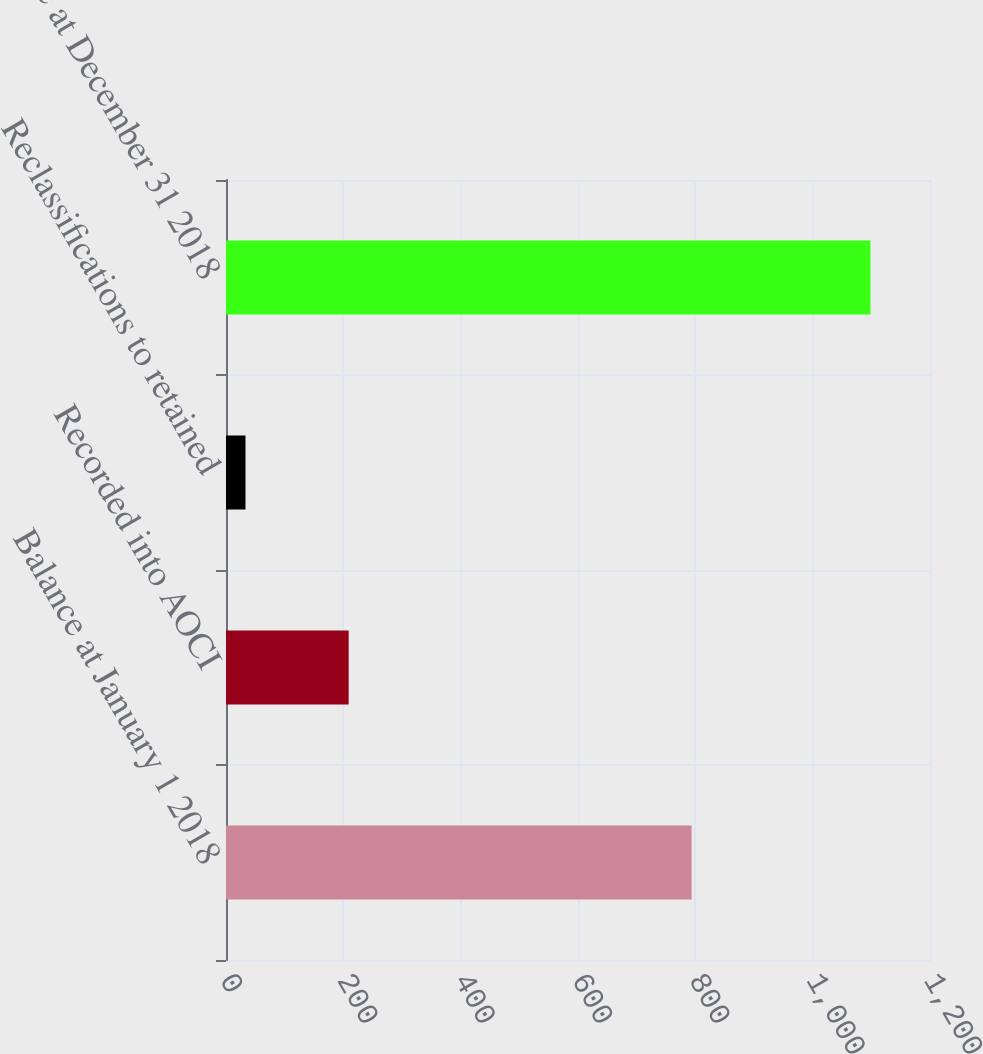<chart> <loc_0><loc_0><loc_500><loc_500><bar_chart><fcel>Balance at January 1 2018<fcel>Recorded into AOCI<fcel>Reclassifications to retained<fcel>Balance at December 31 2018<nl><fcel>793.6<fcel>209.1<fcel>33.2<fcel>1098.5<nl></chart> 